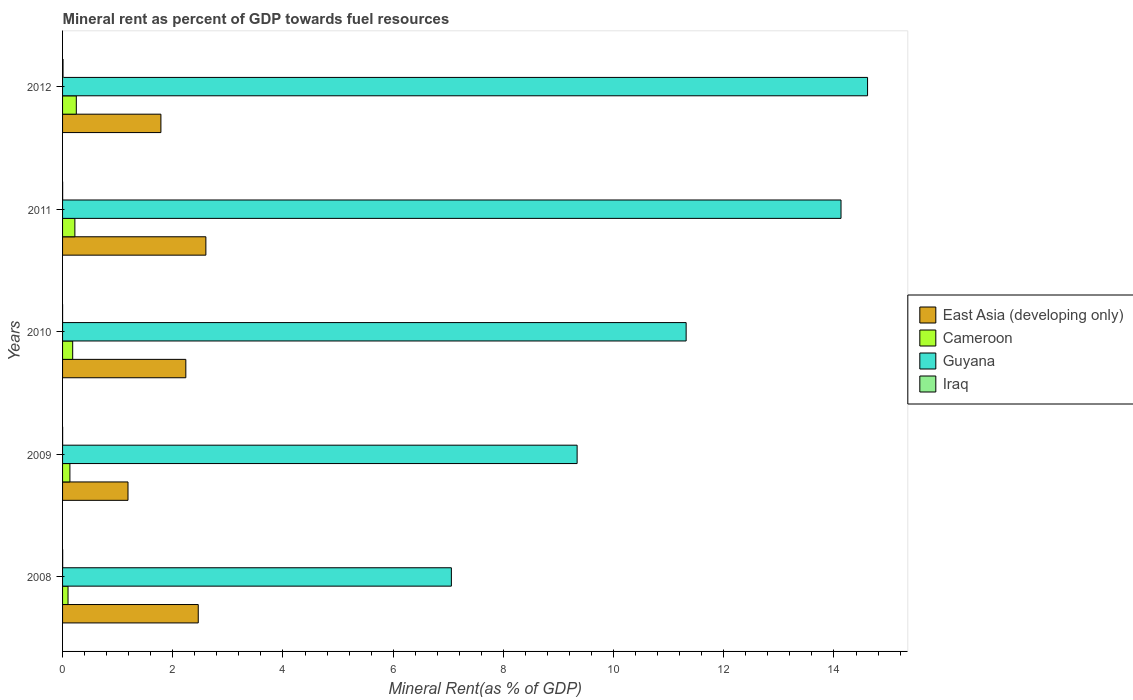How many different coloured bars are there?
Provide a succinct answer. 4. Are the number of bars per tick equal to the number of legend labels?
Keep it short and to the point. Yes. Are the number of bars on each tick of the Y-axis equal?
Provide a short and direct response. Yes. How many bars are there on the 5th tick from the top?
Ensure brevity in your answer.  4. What is the label of the 4th group of bars from the top?
Your response must be concise. 2009. What is the mineral rent in Iraq in 2012?
Make the answer very short. 0.01. Across all years, what is the maximum mineral rent in Cameroon?
Provide a succinct answer. 0.25. Across all years, what is the minimum mineral rent in Guyana?
Your answer should be very brief. 7.06. In which year was the mineral rent in Guyana minimum?
Provide a short and direct response. 2008. What is the total mineral rent in Cameroon in the graph?
Your response must be concise. 0.89. What is the difference between the mineral rent in Guyana in 2008 and that in 2012?
Provide a succinct answer. -7.55. What is the difference between the mineral rent in Guyana in 2008 and the mineral rent in Iraq in 2012?
Offer a terse response. 7.05. What is the average mineral rent in East Asia (developing only) per year?
Provide a succinct answer. 2.05. In the year 2010, what is the difference between the mineral rent in Iraq and mineral rent in Cameroon?
Offer a very short reply. -0.18. In how many years, is the mineral rent in Guyana greater than 2.4 %?
Ensure brevity in your answer.  5. What is the ratio of the mineral rent in Iraq in 2010 to that in 2012?
Provide a succinct answer. 0.03. Is the mineral rent in Iraq in 2008 less than that in 2010?
Make the answer very short. No. What is the difference between the highest and the second highest mineral rent in Cameroon?
Make the answer very short. 0.03. What is the difference between the highest and the lowest mineral rent in Iraq?
Provide a succinct answer. 0.01. In how many years, is the mineral rent in Iraq greater than the average mineral rent in Iraq taken over all years?
Your response must be concise. 1. Is it the case that in every year, the sum of the mineral rent in Cameroon and mineral rent in Guyana is greater than the sum of mineral rent in East Asia (developing only) and mineral rent in Iraq?
Provide a succinct answer. Yes. What does the 3rd bar from the top in 2009 represents?
Offer a very short reply. Cameroon. What does the 2nd bar from the bottom in 2009 represents?
Give a very brief answer. Cameroon. How many bars are there?
Your answer should be compact. 20. How many legend labels are there?
Your response must be concise. 4. What is the title of the graph?
Make the answer very short. Mineral rent as percent of GDP towards fuel resources. What is the label or title of the X-axis?
Your answer should be very brief. Mineral Rent(as % of GDP). What is the label or title of the Y-axis?
Provide a short and direct response. Years. What is the Mineral Rent(as % of GDP) in East Asia (developing only) in 2008?
Ensure brevity in your answer.  2.46. What is the Mineral Rent(as % of GDP) of Cameroon in 2008?
Give a very brief answer. 0.1. What is the Mineral Rent(as % of GDP) in Guyana in 2008?
Offer a very short reply. 7.06. What is the Mineral Rent(as % of GDP) of Iraq in 2008?
Your answer should be compact. 0. What is the Mineral Rent(as % of GDP) in East Asia (developing only) in 2009?
Your response must be concise. 1.19. What is the Mineral Rent(as % of GDP) of Cameroon in 2009?
Your answer should be very brief. 0.13. What is the Mineral Rent(as % of GDP) in Guyana in 2009?
Offer a terse response. 9.34. What is the Mineral Rent(as % of GDP) in Iraq in 2009?
Make the answer very short. 0. What is the Mineral Rent(as % of GDP) of East Asia (developing only) in 2010?
Ensure brevity in your answer.  2.24. What is the Mineral Rent(as % of GDP) of Cameroon in 2010?
Offer a very short reply. 0.18. What is the Mineral Rent(as % of GDP) of Guyana in 2010?
Make the answer very short. 11.32. What is the Mineral Rent(as % of GDP) of Iraq in 2010?
Make the answer very short. 0. What is the Mineral Rent(as % of GDP) in East Asia (developing only) in 2011?
Provide a short and direct response. 2.6. What is the Mineral Rent(as % of GDP) in Cameroon in 2011?
Your answer should be very brief. 0.22. What is the Mineral Rent(as % of GDP) in Guyana in 2011?
Your answer should be compact. 14.13. What is the Mineral Rent(as % of GDP) of Iraq in 2011?
Provide a succinct answer. 0. What is the Mineral Rent(as % of GDP) of East Asia (developing only) in 2012?
Make the answer very short. 1.78. What is the Mineral Rent(as % of GDP) of Cameroon in 2012?
Your answer should be very brief. 0.25. What is the Mineral Rent(as % of GDP) in Guyana in 2012?
Offer a terse response. 14.61. What is the Mineral Rent(as % of GDP) in Iraq in 2012?
Give a very brief answer. 0.01. Across all years, what is the maximum Mineral Rent(as % of GDP) in East Asia (developing only)?
Give a very brief answer. 2.6. Across all years, what is the maximum Mineral Rent(as % of GDP) of Cameroon?
Keep it short and to the point. 0.25. Across all years, what is the maximum Mineral Rent(as % of GDP) of Guyana?
Keep it short and to the point. 14.61. Across all years, what is the maximum Mineral Rent(as % of GDP) in Iraq?
Provide a succinct answer. 0.01. Across all years, what is the minimum Mineral Rent(as % of GDP) of East Asia (developing only)?
Make the answer very short. 1.19. Across all years, what is the minimum Mineral Rent(as % of GDP) of Cameroon?
Provide a succinct answer. 0.1. Across all years, what is the minimum Mineral Rent(as % of GDP) of Guyana?
Offer a very short reply. 7.06. Across all years, what is the minimum Mineral Rent(as % of GDP) of Iraq?
Your answer should be very brief. 0. What is the total Mineral Rent(as % of GDP) in East Asia (developing only) in the graph?
Offer a terse response. 10.27. What is the total Mineral Rent(as % of GDP) in Guyana in the graph?
Ensure brevity in your answer.  56.45. What is the total Mineral Rent(as % of GDP) in Iraq in the graph?
Ensure brevity in your answer.  0.01. What is the difference between the Mineral Rent(as % of GDP) in East Asia (developing only) in 2008 and that in 2009?
Keep it short and to the point. 1.28. What is the difference between the Mineral Rent(as % of GDP) of Cameroon in 2008 and that in 2009?
Your response must be concise. -0.03. What is the difference between the Mineral Rent(as % of GDP) of Guyana in 2008 and that in 2009?
Provide a succinct answer. -2.28. What is the difference between the Mineral Rent(as % of GDP) in Iraq in 2008 and that in 2009?
Give a very brief answer. 0. What is the difference between the Mineral Rent(as % of GDP) in East Asia (developing only) in 2008 and that in 2010?
Offer a terse response. 0.23. What is the difference between the Mineral Rent(as % of GDP) of Cameroon in 2008 and that in 2010?
Give a very brief answer. -0.08. What is the difference between the Mineral Rent(as % of GDP) in Guyana in 2008 and that in 2010?
Offer a terse response. -4.26. What is the difference between the Mineral Rent(as % of GDP) in Iraq in 2008 and that in 2010?
Your answer should be very brief. 0. What is the difference between the Mineral Rent(as % of GDP) of East Asia (developing only) in 2008 and that in 2011?
Give a very brief answer. -0.14. What is the difference between the Mineral Rent(as % of GDP) in Cameroon in 2008 and that in 2011?
Ensure brevity in your answer.  -0.12. What is the difference between the Mineral Rent(as % of GDP) of Guyana in 2008 and that in 2011?
Your answer should be compact. -7.07. What is the difference between the Mineral Rent(as % of GDP) in Iraq in 2008 and that in 2011?
Provide a succinct answer. 0. What is the difference between the Mineral Rent(as % of GDP) of East Asia (developing only) in 2008 and that in 2012?
Provide a succinct answer. 0.68. What is the difference between the Mineral Rent(as % of GDP) in Cameroon in 2008 and that in 2012?
Your answer should be very brief. -0.15. What is the difference between the Mineral Rent(as % of GDP) of Guyana in 2008 and that in 2012?
Offer a terse response. -7.55. What is the difference between the Mineral Rent(as % of GDP) in Iraq in 2008 and that in 2012?
Keep it short and to the point. -0.01. What is the difference between the Mineral Rent(as % of GDP) in East Asia (developing only) in 2009 and that in 2010?
Your answer should be very brief. -1.05. What is the difference between the Mineral Rent(as % of GDP) in Cameroon in 2009 and that in 2010?
Your answer should be very brief. -0.05. What is the difference between the Mineral Rent(as % of GDP) of Guyana in 2009 and that in 2010?
Your answer should be very brief. -1.98. What is the difference between the Mineral Rent(as % of GDP) in Iraq in 2009 and that in 2010?
Keep it short and to the point. 0. What is the difference between the Mineral Rent(as % of GDP) in East Asia (developing only) in 2009 and that in 2011?
Your answer should be compact. -1.41. What is the difference between the Mineral Rent(as % of GDP) in Cameroon in 2009 and that in 2011?
Ensure brevity in your answer.  -0.09. What is the difference between the Mineral Rent(as % of GDP) in Guyana in 2009 and that in 2011?
Keep it short and to the point. -4.79. What is the difference between the Mineral Rent(as % of GDP) in Iraq in 2009 and that in 2011?
Offer a very short reply. -0. What is the difference between the Mineral Rent(as % of GDP) in East Asia (developing only) in 2009 and that in 2012?
Your answer should be very brief. -0.6. What is the difference between the Mineral Rent(as % of GDP) of Cameroon in 2009 and that in 2012?
Your response must be concise. -0.12. What is the difference between the Mineral Rent(as % of GDP) in Guyana in 2009 and that in 2012?
Ensure brevity in your answer.  -5.27. What is the difference between the Mineral Rent(as % of GDP) in Iraq in 2009 and that in 2012?
Your answer should be very brief. -0.01. What is the difference between the Mineral Rent(as % of GDP) of East Asia (developing only) in 2010 and that in 2011?
Your response must be concise. -0.36. What is the difference between the Mineral Rent(as % of GDP) of Cameroon in 2010 and that in 2011?
Provide a succinct answer. -0.04. What is the difference between the Mineral Rent(as % of GDP) in Guyana in 2010 and that in 2011?
Ensure brevity in your answer.  -2.81. What is the difference between the Mineral Rent(as % of GDP) of Iraq in 2010 and that in 2011?
Your answer should be compact. -0. What is the difference between the Mineral Rent(as % of GDP) in East Asia (developing only) in 2010 and that in 2012?
Ensure brevity in your answer.  0.45. What is the difference between the Mineral Rent(as % of GDP) in Cameroon in 2010 and that in 2012?
Make the answer very short. -0.07. What is the difference between the Mineral Rent(as % of GDP) of Guyana in 2010 and that in 2012?
Your answer should be very brief. -3.29. What is the difference between the Mineral Rent(as % of GDP) in Iraq in 2010 and that in 2012?
Provide a short and direct response. -0.01. What is the difference between the Mineral Rent(as % of GDP) of East Asia (developing only) in 2011 and that in 2012?
Your answer should be very brief. 0.82. What is the difference between the Mineral Rent(as % of GDP) of Cameroon in 2011 and that in 2012?
Ensure brevity in your answer.  -0.03. What is the difference between the Mineral Rent(as % of GDP) of Guyana in 2011 and that in 2012?
Offer a terse response. -0.48. What is the difference between the Mineral Rent(as % of GDP) of Iraq in 2011 and that in 2012?
Make the answer very short. -0.01. What is the difference between the Mineral Rent(as % of GDP) in East Asia (developing only) in 2008 and the Mineral Rent(as % of GDP) in Cameroon in 2009?
Keep it short and to the point. 2.33. What is the difference between the Mineral Rent(as % of GDP) of East Asia (developing only) in 2008 and the Mineral Rent(as % of GDP) of Guyana in 2009?
Your response must be concise. -6.88. What is the difference between the Mineral Rent(as % of GDP) in East Asia (developing only) in 2008 and the Mineral Rent(as % of GDP) in Iraq in 2009?
Your answer should be very brief. 2.46. What is the difference between the Mineral Rent(as % of GDP) of Cameroon in 2008 and the Mineral Rent(as % of GDP) of Guyana in 2009?
Provide a succinct answer. -9.24. What is the difference between the Mineral Rent(as % of GDP) in Cameroon in 2008 and the Mineral Rent(as % of GDP) in Iraq in 2009?
Your answer should be very brief. 0.1. What is the difference between the Mineral Rent(as % of GDP) of Guyana in 2008 and the Mineral Rent(as % of GDP) of Iraq in 2009?
Provide a short and direct response. 7.06. What is the difference between the Mineral Rent(as % of GDP) of East Asia (developing only) in 2008 and the Mineral Rent(as % of GDP) of Cameroon in 2010?
Your response must be concise. 2.28. What is the difference between the Mineral Rent(as % of GDP) in East Asia (developing only) in 2008 and the Mineral Rent(as % of GDP) in Guyana in 2010?
Offer a very short reply. -8.85. What is the difference between the Mineral Rent(as % of GDP) in East Asia (developing only) in 2008 and the Mineral Rent(as % of GDP) in Iraq in 2010?
Your response must be concise. 2.46. What is the difference between the Mineral Rent(as % of GDP) of Cameroon in 2008 and the Mineral Rent(as % of GDP) of Guyana in 2010?
Your answer should be very brief. -11.22. What is the difference between the Mineral Rent(as % of GDP) of Cameroon in 2008 and the Mineral Rent(as % of GDP) of Iraq in 2010?
Your answer should be very brief. 0.1. What is the difference between the Mineral Rent(as % of GDP) of Guyana in 2008 and the Mineral Rent(as % of GDP) of Iraq in 2010?
Make the answer very short. 7.06. What is the difference between the Mineral Rent(as % of GDP) in East Asia (developing only) in 2008 and the Mineral Rent(as % of GDP) in Cameroon in 2011?
Offer a very short reply. 2.24. What is the difference between the Mineral Rent(as % of GDP) in East Asia (developing only) in 2008 and the Mineral Rent(as % of GDP) in Guyana in 2011?
Offer a terse response. -11.67. What is the difference between the Mineral Rent(as % of GDP) in East Asia (developing only) in 2008 and the Mineral Rent(as % of GDP) in Iraq in 2011?
Keep it short and to the point. 2.46. What is the difference between the Mineral Rent(as % of GDP) in Cameroon in 2008 and the Mineral Rent(as % of GDP) in Guyana in 2011?
Your answer should be very brief. -14.03. What is the difference between the Mineral Rent(as % of GDP) of Cameroon in 2008 and the Mineral Rent(as % of GDP) of Iraq in 2011?
Ensure brevity in your answer.  0.1. What is the difference between the Mineral Rent(as % of GDP) in Guyana in 2008 and the Mineral Rent(as % of GDP) in Iraq in 2011?
Provide a succinct answer. 7.05. What is the difference between the Mineral Rent(as % of GDP) of East Asia (developing only) in 2008 and the Mineral Rent(as % of GDP) of Cameroon in 2012?
Your response must be concise. 2.21. What is the difference between the Mineral Rent(as % of GDP) in East Asia (developing only) in 2008 and the Mineral Rent(as % of GDP) in Guyana in 2012?
Offer a terse response. -12.15. What is the difference between the Mineral Rent(as % of GDP) in East Asia (developing only) in 2008 and the Mineral Rent(as % of GDP) in Iraq in 2012?
Your answer should be compact. 2.45. What is the difference between the Mineral Rent(as % of GDP) in Cameroon in 2008 and the Mineral Rent(as % of GDP) in Guyana in 2012?
Give a very brief answer. -14.51. What is the difference between the Mineral Rent(as % of GDP) of Cameroon in 2008 and the Mineral Rent(as % of GDP) of Iraq in 2012?
Offer a terse response. 0.09. What is the difference between the Mineral Rent(as % of GDP) in Guyana in 2008 and the Mineral Rent(as % of GDP) in Iraq in 2012?
Provide a short and direct response. 7.05. What is the difference between the Mineral Rent(as % of GDP) in East Asia (developing only) in 2009 and the Mineral Rent(as % of GDP) in Guyana in 2010?
Offer a very short reply. -10.13. What is the difference between the Mineral Rent(as % of GDP) in East Asia (developing only) in 2009 and the Mineral Rent(as % of GDP) in Iraq in 2010?
Give a very brief answer. 1.19. What is the difference between the Mineral Rent(as % of GDP) of Cameroon in 2009 and the Mineral Rent(as % of GDP) of Guyana in 2010?
Give a very brief answer. -11.18. What is the difference between the Mineral Rent(as % of GDP) of Cameroon in 2009 and the Mineral Rent(as % of GDP) of Iraq in 2010?
Ensure brevity in your answer.  0.13. What is the difference between the Mineral Rent(as % of GDP) in Guyana in 2009 and the Mineral Rent(as % of GDP) in Iraq in 2010?
Make the answer very short. 9.34. What is the difference between the Mineral Rent(as % of GDP) of East Asia (developing only) in 2009 and the Mineral Rent(as % of GDP) of Cameroon in 2011?
Your answer should be compact. 0.96. What is the difference between the Mineral Rent(as % of GDP) in East Asia (developing only) in 2009 and the Mineral Rent(as % of GDP) in Guyana in 2011?
Offer a terse response. -12.94. What is the difference between the Mineral Rent(as % of GDP) in East Asia (developing only) in 2009 and the Mineral Rent(as % of GDP) in Iraq in 2011?
Provide a short and direct response. 1.19. What is the difference between the Mineral Rent(as % of GDP) of Cameroon in 2009 and the Mineral Rent(as % of GDP) of Guyana in 2011?
Your answer should be very brief. -13.99. What is the difference between the Mineral Rent(as % of GDP) in Cameroon in 2009 and the Mineral Rent(as % of GDP) in Iraq in 2011?
Make the answer very short. 0.13. What is the difference between the Mineral Rent(as % of GDP) of Guyana in 2009 and the Mineral Rent(as % of GDP) of Iraq in 2011?
Your answer should be compact. 9.34. What is the difference between the Mineral Rent(as % of GDP) of East Asia (developing only) in 2009 and the Mineral Rent(as % of GDP) of Cameroon in 2012?
Keep it short and to the point. 0.94. What is the difference between the Mineral Rent(as % of GDP) in East Asia (developing only) in 2009 and the Mineral Rent(as % of GDP) in Guyana in 2012?
Offer a terse response. -13.42. What is the difference between the Mineral Rent(as % of GDP) of East Asia (developing only) in 2009 and the Mineral Rent(as % of GDP) of Iraq in 2012?
Your response must be concise. 1.18. What is the difference between the Mineral Rent(as % of GDP) in Cameroon in 2009 and the Mineral Rent(as % of GDP) in Guyana in 2012?
Ensure brevity in your answer.  -14.48. What is the difference between the Mineral Rent(as % of GDP) in Cameroon in 2009 and the Mineral Rent(as % of GDP) in Iraq in 2012?
Give a very brief answer. 0.12. What is the difference between the Mineral Rent(as % of GDP) in Guyana in 2009 and the Mineral Rent(as % of GDP) in Iraq in 2012?
Give a very brief answer. 9.33. What is the difference between the Mineral Rent(as % of GDP) in East Asia (developing only) in 2010 and the Mineral Rent(as % of GDP) in Cameroon in 2011?
Your response must be concise. 2.01. What is the difference between the Mineral Rent(as % of GDP) of East Asia (developing only) in 2010 and the Mineral Rent(as % of GDP) of Guyana in 2011?
Provide a succinct answer. -11.89. What is the difference between the Mineral Rent(as % of GDP) of East Asia (developing only) in 2010 and the Mineral Rent(as % of GDP) of Iraq in 2011?
Your response must be concise. 2.24. What is the difference between the Mineral Rent(as % of GDP) in Cameroon in 2010 and the Mineral Rent(as % of GDP) in Guyana in 2011?
Your response must be concise. -13.94. What is the difference between the Mineral Rent(as % of GDP) in Cameroon in 2010 and the Mineral Rent(as % of GDP) in Iraq in 2011?
Give a very brief answer. 0.18. What is the difference between the Mineral Rent(as % of GDP) in Guyana in 2010 and the Mineral Rent(as % of GDP) in Iraq in 2011?
Ensure brevity in your answer.  11.32. What is the difference between the Mineral Rent(as % of GDP) in East Asia (developing only) in 2010 and the Mineral Rent(as % of GDP) in Cameroon in 2012?
Make the answer very short. 1.99. What is the difference between the Mineral Rent(as % of GDP) in East Asia (developing only) in 2010 and the Mineral Rent(as % of GDP) in Guyana in 2012?
Provide a succinct answer. -12.37. What is the difference between the Mineral Rent(as % of GDP) in East Asia (developing only) in 2010 and the Mineral Rent(as % of GDP) in Iraq in 2012?
Provide a succinct answer. 2.23. What is the difference between the Mineral Rent(as % of GDP) of Cameroon in 2010 and the Mineral Rent(as % of GDP) of Guyana in 2012?
Your answer should be very brief. -14.43. What is the difference between the Mineral Rent(as % of GDP) of Cameroon in 2010 and the Mineral Rent(as % of GDP) of Iraq in 2012?
Provide a succinct answer. 0.18. What is the difference between the Mineral Rent(as % of GDP) of Guyana in 2010 and the Mineral Rent(as % of GDP) of Iraq in 2012?
Provide a short and direct response. 11.31. What is the difference between the Mineral Rent(as % of GDP) in East Asia (developing only) in 2011 and the Mineral Rent(as % of GDP) in Cameroon in 2012?
Keep it short and to the point. 2.35. What is the difference between the Mineral Rent(as % of GDP) of East Asia (developing only) in 2011 and the Mineral Rent(as % of GDP) of Guyana in 2012?
Provide a short and direct response. -12.01. What is the difference between the Mineral Rent(as % of GDP) in East Asia (developing only) in 2011 and the Mineral Rent(as % of GDP) in Iraq in 2012?
Keep it short and to the point. 2.59. What is the difference between the Mineral Rent(as % of GDP) in Cameroon in 2011 and the Mineral Rent(as % of GDP) in Guyana in 2012?
Give a very brief answer. -14.39. What is the difference between the Mineral Rent(as % of GDP) in Cameroon in 2011 and the Mineral Rent(as % of GDP) in Iraq in 2012?
Ensure brevity in your answer.  0.21. What is the difference between the Mineral Rent(as % of GDP) of Guyana in 2011 and the Mineral Rent(as % of GDP) of Iraq in 2012?
Offer a very short reply. 14.12. What is the average Mineral Rent(as % of GDP) of East Asia (developing only) per year?
Offer a terse response. 2.05. What is the average Mineral Rent(as % of GDP) in Cameroon per year?
Keep it short and to the point. 0.18. What is the average Mineral Rent(as % of GDP) in Guyana per year?
Your answer should be compact. 11.29. What is the average Mineral Rent(as % of GDP) in Iraq per year?
Keep it short and to the point. 0. In the year 2008, what is the difference between the Mineral Rent(as % of GDP) of East Asia (developing only) and Mineral Rent(as % of GDP) of Cameroon?
Give a very brief answer. 2.36. In the year 2008, what is the difference between the Mineral Rent(as % of GDP) of East Asia (developing only) and Mineral Rent(as % of GDP) of Guyana?
Provide a succinct answer. -4.59. In the year 2008, what is the difference between the Mineral Rent(as % of GDP) in East Asia (developing only) and Mineral Rent(as % of GDP) in Iraq?
Give a very brief answer. 2.46. In the year 2008, what is the difference between the Mineral Rent(as % of GDP) in Cameroon and Mineral Rent(as % of GDP) in Guyana?
Your answer should be very brief. -6.96. In the year 2008, what is the difference between the Mineral Rent(as % of GDP) of Cameroon and Mineral Rent(as % of GDP) of Iraq?
Your answer should be compact. 0.1. In the year 2008, what is the difference between the Mineral Rent(as % of GDP) in Guyana and Mineral Rent(as % of GDP) in Iraq?
Offer a very short reply. 7.05. In the year 2009, what is the difference between the Mineral Rent(as % of GDP) in East Asia (developing only) and Mineral Rent(as % of GDP) in Cameroon?
Provide a succinct answer. 1.05. In the year 2009, what is the difference between the Mineral Rent(as % of GDP) of East Asia (developing only) and Mineral Rent(as % of GDP) of Guyana?
Your answer should be very brief. -8.15. In the year 2009, what is the difference between the Mineral Rent(as % of GDP) of East Asia (developing only) and Mineral Rent(as % of GDP) of Iraq?
Give a very brief answer. 1.19. In the year 2009, what is the difference between the Mineral Rent(as % of GDP) of Cameroon and Mineral Rent(as % of GDP) of Guyana?
Provide a short and direct response. -9.21. In the year 2009, what is the difference between the Mineral Rent(as % of GDP) in Cameroon and Mineral Rent(as % of GDP) in Iraq?
Provide a short and direct response. 0.13. In the year 2009, what is the difference between the Mineral Rent(as % of GDP) of Guyana and Mineral Rent(as % of GDP) of Iraq?
Your answer should be compact. 9.34. In the year 2010, what is the difference between the Mineral Rent(as % of GDP) of East Asia (developing only) and Mineral Rent(as % of GDP) of Cameroon?
Provide a short and direct response. 2.05. In the year 2010, what is the difference between the Mineral Rent(as % of GDP) in East Asia (developing only) and Mineral Rent(as % of GDP) in Guyana?
Your response must be concise. -9.08. In the year 2010, what is the difference between the Mineral Rent(as % of GDP) in East Asia (developing only) and Mineral Rent(as % of GDP) in Iraq?
Ensure brevity in your answer.  2.24. In the year 2010, what is the difference between the Mineral Rent(as % of GDP) in Cameroon and Mineral Rent(as % of GDP) in Guyana?
Ensure brevity in your answer.  -11.13. In the year 2010, what is the difference between the Mineral Rent(as % of GDP) in Cameroon and Mineral Rent(as % of GDP) in Iraq?
Provide a succinct answer. 0.18. In the year 2010, what is the difference between the Mineral Rent(as % of GDP) in Guyana and Mineral Rent(as % of GDP) in Iraq?
Give a very brief answer. 11.32. In the year 2011, what is the difference between the Mineral Rent(as % of GDP) in East Asia (developing only) and Mineral Rent(as % of GDP) in Cameroon?
Ensure brevity in your answer.  2.38. In the year 2011, what is the difference between the Mineral Rent(as % of GDP) in East Asia (developing only) and Mineral Rent(as % of GDP) in Guyana?
Give a very brief answer. -11.53. In the year 2011, what is the difference between the Mineral Rent(as % of GDP) in East Asia (developing only) and Mineral Rent(as % of GDP) in Iraq?
Keep it short and to the point. 2.6. In the year 2011, what is the difference between the Mineral Rent(as % of GDP) of Cameroon and Mineral Rent(as % of GDP) of Guyana?
Make the answer very short. -13.9. In the year 2011, what is the difference between the Mineral Rent(as % of GDP) in Cameroon and Mineral Rent(as % of GDP) in Iraq?
Make the answer very short. 0.22. In the year 2011, what is the difference between the Mineral Rent(as % of GDP) of Guyana and Mineral Rent(as % of GDP) of Iraq?
Your answer should be very brief. 14.13. In the year 2012, what is the difference between the Mineral Rent(as % of GDP) of East Asia (developing only) and Mineral Rent(as % of GDP) of Cameroon?
Make the answer very short. 1.54. In the year 2012, what is the difference between the Mineral Rent(as % of GDP) of East Asia (developing only) and Mineral Rent(as % of GDP) of Guyana?
Offer a very short reply. -12.82. In the year 2012, what is the difference between the Mineral Rent(as % of GDP) in East Asia (developing only) and Mineral Rent(as % of GDP) in Iraq?
Ensure brevity in your answer.  1.78. In the year 2012, what is the difference between the Mineral Rent(as % of GDP) of Cameroon and Mineral Rent(as % of GDP) of Guyana?
Your answer should be very brief. -14.36. In the year 2012, what is the difference between the Mineral Rent(as % of GDP) in Cameroon and Mineral Rent(as % of GDP) in Iraq?
Ensure brevity in your answer.  0.24. In the year 2012, what is the difference between the Mineral Rent(as % of GDP) in Guyana and Mineral Rent(as % of GDP) in Iraq?
Make the answer very short. 14.6. What is the ratio of the Mineral Rent(as % of GDP) in East Asia (developing only) in 2008 to that in 2009?
Provide a succinct answer. 2.07. What is the ratio of the Mineral Rent(as % of GDP) of Cameroon in 2008 to that in 2009?
Your response must be concise. 0.74. What is the ratio of the Mineral Rent(as % of GDP) in Guyana in 2008 to that in 2009?
Provide a succinct answer. 0.76. What is the ratio of the Mineral Rent(as % of GDP) in Iraq in 2008 to that in 2009?
Make the answer very short. 1.95. What is the ratio of the Mineral Rent(as % of GDP) of East Asia (developing only) in 2008 to that in 2010?
Give a very brief answer. 1.1. What is the ratio of the Mineral Rent(as % of GDP) of Cameroon in 2008 to that in 2010?
Your answer should be very brief. 0.54. What is the ratio of the Mineral Rent(as % of GDP) of Guyana in 2008 to that in 2010?
Your response must be concise. 0.62. What is the ratio of the Mineral Rent(as % of GDP) of Iraq in 2008 to that in 2010?
Ensure brevity in your answer.  7.63. What is the ratio of the Mineral Rent(as % of GDP) of East Asia (developing only) in 2008 to that in 2011?
Your response must be concise. 0.95. What is the ratio of the Mineral Rent(as % of GDP) in Cameroon in 2008 to that in 2011?
Make the answer very short. 0.44. What is the ratio of the Mineral Rent(as % of GDP) in Guyana in 2008 to that in 2011?
Your answer should be compact. 0.5. What is the ratio of the Mineral Rent(as % of GDP) of Iraq in 2008 to that in 2011?
Keep it short and to the point. 1.35. What is the ratio of the Mineral Rent(as % of GDP) of East Asia (developing only) in 2008 to that in 2012?
Make the answer very short. 1.38. What is the ratio of the Mineral Rent(as % of GDP) in Cameroon in 2008 to that in 2012?
Your answer should be compact. 0.4. What is the ratio of the Mineral Rent(as % of GDP) in Guyana in 2008 to that in 2012?
Keep it short and to the point. 0.48. What is the ratio of the Mineral Rent(as % of GDP) of Iraq in 2008 to that in 2012?
Your response must be concise. 0.23. What is the ratio of the Mineral Rent(as % of GDP) in East Asia (developing only) in 2009 to that in 2010?
Offer a terse response. 0.53. What is the ratio of the Mineral Rent(as % of GDP) in Cameroon in 2009 to that in 2010?
Make the answer very short. 0.73. What is the ratio of the Mineral Rent(as % of GDP) in Guyana in 2009 to that in 2010?
Make the answer very short. 0.83. What is the ratio of the Mineral Rent(as % of GDP) in Iraq in 2009 to that in 2010?
Your answer should be very brief. 3.91. What is the ratio of the Mineral Rent(as % of GDP) of East Asia (developing only) in 2009 to that in 2011?
Your response must be concise. 0.46. What is the ratio of the Mineral Rent(as % of GDP) in Cameroon in 2009 to that in 2011?
Provide a succinct answer. 0.6. What is the ratio of the Mineral Rent(as % of GDP) of Guyana in 2009 to that in 2011?
Provide a succinct answer. 0.66. What is the ratio of the Mineral Rent(as % of GDP) in Iraq in 2009 to that in 2011?
Offer a terse response. 0.69. What is the ratio of the Mineral Rent(as % of GDP) of East Asia (developing only) in 2009 to that in 2012?
Your answer should be compact. 0.67. What is the ratio of the Mineral Rent(as % of GDP) in Cameroon in 2009 to that in 2012?
Ensure brevity in your answer.  0.53. What is the ratio of the Mineral Rent(as % of GDP) in Guyana in 2009 to that in 2012?
Keep it short and to the point. 0.64. What is the ratio of the Mineral Rent(as % of GDP) of Iraq in 2009 to that in 2012?
Offer a terse response. 0.12. What is the ratio of the Mineral Rent(as % of GDP) in East Asia (developing only) in 2010 to that in 2011?
Your answer should be very brief. 0.86. What is the ratio of the Mineral Rent(as % of GDP) in Cameroon in 2010 to that in 2011?
Your answer should be compact. 0.82. What is the ratio of the Mineral Rent(as % of GDP) of Guyana in 2010 to that in 2011?
Your answer should be very brief. 0.8. What is the ratio of the Mineral Rent(as % of GDP) in Iraq in 2010 to that in 2011?
Provide a succinct answer. 0.18. What is the ratio of the Mineral Rent(as % of GDP) of East Asia (developing only) in 2010 to that in 2012?
Keep it short and to the point. 1.25. What is the ratio of the Mineral Rent(as % of GDP) of Cameroon in 2010 to that in 2012?
Provide a succinct answer. 0.74. What is the ratio of the Mineral Rent(as % of GDP) in Guyana in 2010 to that in 2012?
Your response must be concise. 0.77. What is the ratio of the Mineral Rent(as % of GDP) in Iraq in 2010 to that in 2012?
Ensure brevity in your answer.  0.03. What is the ratio of the Mineral Rent(as % of GDP) in East Asia (developing only) in 2011 to that in 2012?
Provide a short and direct response. 1.46. What is the ratio of the Mineral Rent(as % of GDP) of Cameroon in 2011 to that in 2012?
Provide a succinct answer. 0.9. What is the ratio of the Mineral Rent(as % of GDP) of Guyana in 2011 to that in 2012?
Provide a succinct answer. 0.97. What is the ratio of the Mineral Rent(as % of GDP) in Iraq in 2011 to that in 2012?
Provide a succinct answer. 0.17. What is the difference between the highest and the second highest Mineral Rent(as % of GDP) of East Asia (developing only)?
Offer a terse response. 0.14. What is the difference between the highest and the second highest Mineral Rent(as % of GDP) of Cameroon?
Your answer should be compact. 0.03. What is the difference between the highest and the second highest Mineral Rent(as % of GDP) in Guyana?
Your answer should be compact. 0.48. What is the difference between the highest and the second highest Mineral Rent(as % of GDP) of Iraq?
Provide a succinct answer. 0.01. What is the difference between the highest and the lowest Mineral Rent(as % of GDP) in East Asia (developing only)?
Offer a very short reply. 1.41. What is the difference between the highest and the lowest Mineral Rent(as % of GDP) in Cameroon?
Make the answer very short. 0.15. What is the difference between the highest and the lowest Mineral Rent(as % of GDP) of Guyana?
Offer a very short reply. 7.55. What is the difference between the highest and the lowest Mineral Rent(as % of GDP) of Iraq?
Provide a succinct answer. 0.01. 